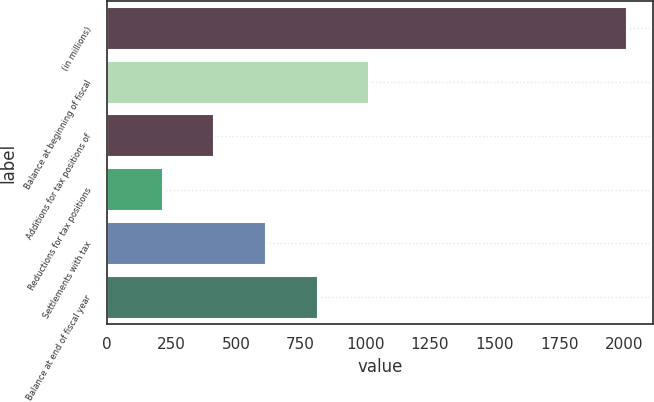Convert chart. <chart><loc_0><loc_0><loc_500><loc_500><bar_chart><fcel>(in millions)<fcel>Balance at beginning of fiscal<fcel>Additions for tax positions of<fcel>Reductions for tax positions<fcel>Settlements with tax<fcel>Balance at end of fiscal year<nl><fcel>2014<fcel>1015<fcel>415.6<fcel>215.8<fcel>615.4<fcel>815.2<nl></chart> 